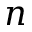<formula> <loc_0><loc_0><loc_500><loc_500>n</formula> 